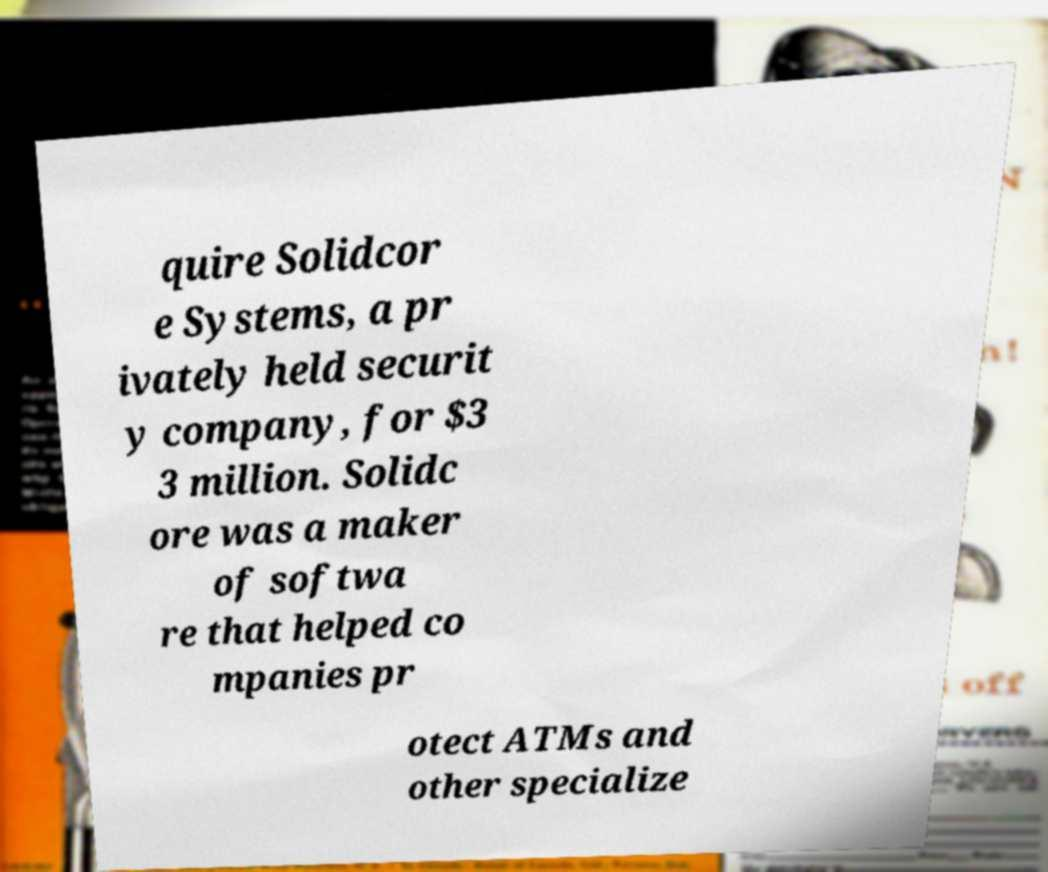Can you accurately transcribe the text from the provided image for me? quire Solidcor e Systems, a pr ivately held securit y company, for $3 3 million. Solidc ore was a maker of softwa re that helped co mpanies pr otect ATMs and other specialize 